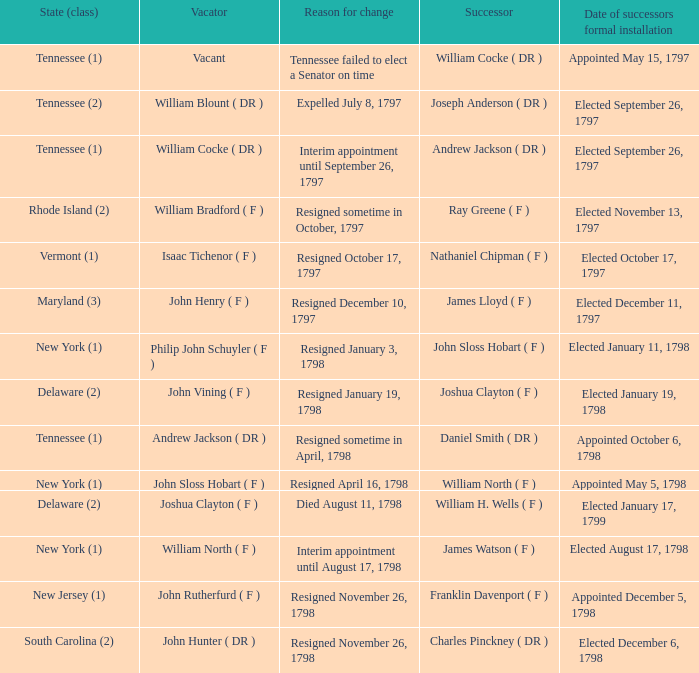What is the total number of dates of successor formal installation when the vacator was Joshua Clayton ( F )? 1.0. 